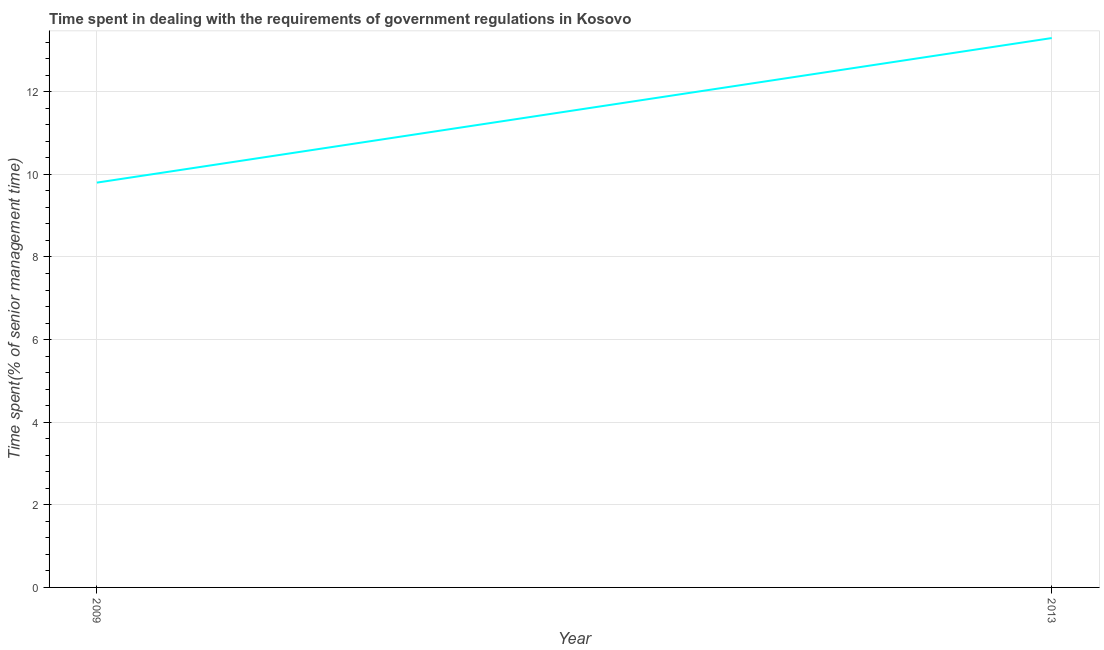What is the time spent in dealing with government regulations in 2009?
Provide a short and direct response. 9.8. Across all years, what is the maximum time spent in dealing with government regulations?
Make the answer very short. 13.3. What is the sum of the time spent in dealing with government regulations?
Offer a terse response. 23.1. What is the average time spent in dealing with government regulations per year?
Give a very brief answer. 11.55. What is the median time spent in dealing with government regulations?
Keep it short and to the point. 11.55. In how many years, is the time spent in dealing with government regulations greater than 7.2 %?
Keep it short and to the point. 2. What is the ratio of the time spent in dealing with government regulations in 2009 to that in 2013?
Provide a succinct answer. 0.74. In how many years, is the time spent in dealing with government regulations greater than the average time spent in dealing with government regulations taken over all years?
Provide a succinct answer. 1. Does the time spent in dealing with government regulations monotonically increase over the years?
Give a very brief answer. Yes. How many lines are there?
Keep it short and to the point. 1. How many years are there in the graph?
Provide a short and direct response. 2. What is the difference between two consecutive major ticks on the Y-axis?
Your answer should be compact. 2. Are the values on the major ticks of Y-axis written in scientific E-notation?
Offer a terse response. No. Does the graph contain any zero values?
Ensure brevity in your answer.  No. What is the title of the graph?
Your answer should be very brief. Time spent in dealing with the requirements of government regulations in Kosovo. What is the label or title of the X-axis?
Your response must be concise. Year. What is the label or title of the Y-axis?
Offer a very short reply. Time spent(% of senior management time). What is the difference between the Time spent(% of senior management time) in 2009 and 2013?
Give a very brief answer. -3.5. What is the ratio of the Time spent(% of senior management time) in 2009 to that in 2013?
Offer a terse response. 0.74. 